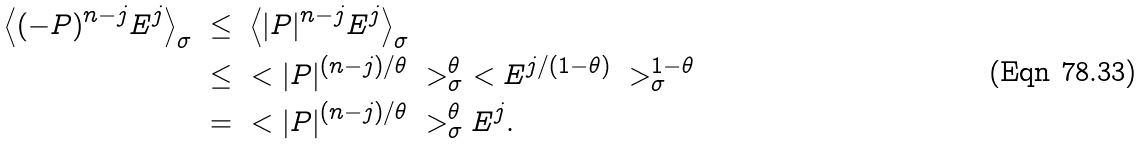<formula> <loc_0><loc_0><loc_500><loc_500>\left \langle ( - P ) ^ { n - j } E ^ { j } \right \rangle _ { \sigma } & \ \leq \ \left \langle | P | ^ { n - j } E ^ { j } \right \rangle _ { \sigma } \\ & \ \leq \ \ < | P | ^ { ( n - j ) / \theta } \ > _ { \sigma } ^ { \theta } \ < E ^ { j / ( 1 - \theta ) } \ > _ { \sigma } ^ { 1 - \theta } \\ & \ = \ \ < | P | ^ { ( n - j ) / \theta } \ > _ { \sigma } ^ { \theta } E ^ { j } .</formula> 